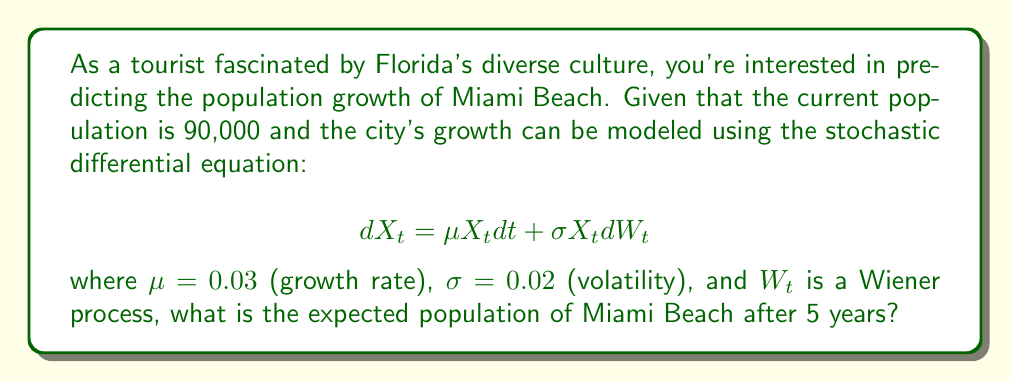Could you help me with this problem? To solve this problem, we'll use the properties of geometric Brownian motion, which is described by the given stochastic differential equation.

Step 1: Identify the solution to the SDE
The solution to this SDE is given by:
$$X_t = X_0 \exp\left(\left(\mu - \frac{\sigma^2}{2}\right)t + \sigma W_t\right)$$

Step 2: Calculate the expected value
The expected value of $X_t$ is:
$$E[X_t] = X_0 \exp(\mu t)$$

Step 3: Plug in the values
$X_0 = 90,000$ (initial population)
$\mu = 0.03$ (growth rate)
$t = 5$ (years)

$$E[X_5] = 90,000 \exp(0.03 \cdot 5)$$

Step 4: Calculate the result
$$E[X_5] = 90,000 \exp(0.15) \approx 90,000 \cdot 1.1618 \approx 104,562$$

Therefore, the expected population of Miami Beach after 5 years is approximately 104,562 people.
Answer: 104,562 people 